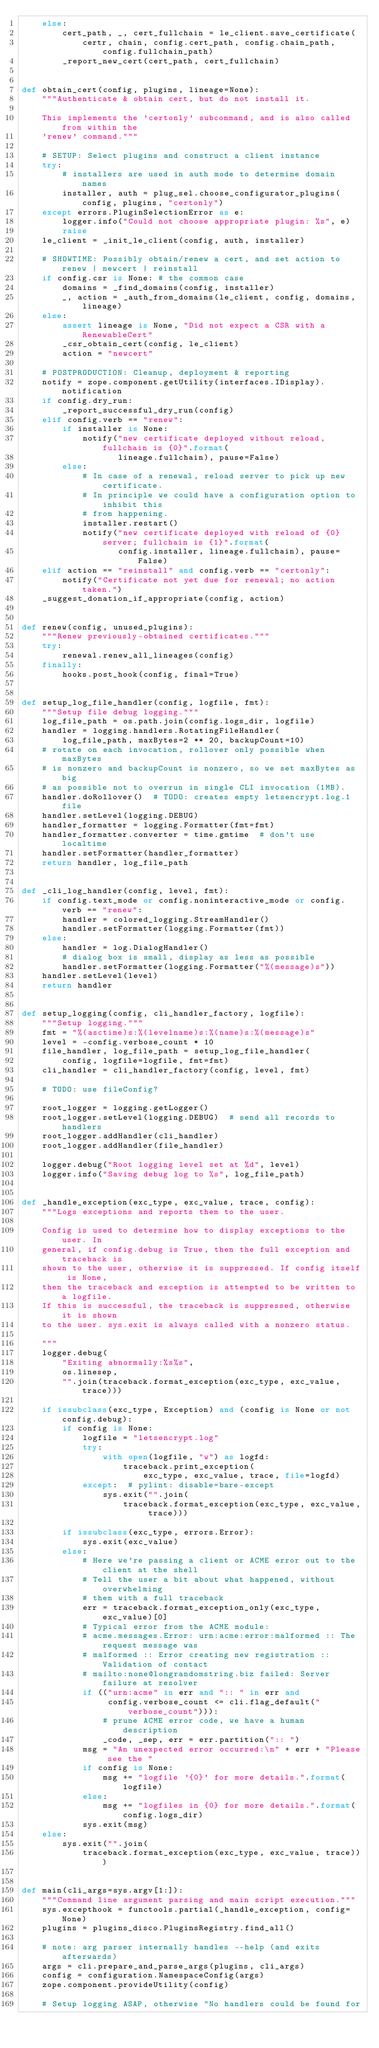Convert code to text. <code><loc_0><loc_0><loc_500><loc_500><_Python_>    else:
        cert_path, _, cert_fullchain = le_client.save_certificate(
            certr, chain, config.cert_path, config.chain_path, config.fullchain_path)
        _report_new_cert(cert_path, cert_fullchain)


def obtain_cert(config, plugins, lineage=None):
    """Authenticate & obtain cert, but do not install it.

    This implements the 'certonly' subcommand, and is also called from within the
    'renew' command."""

    # SETUP: Select plugins and construct a client instance
    try:
        # installers are used in auth mode to determine domain names
        installer, auth = plug_sel.choose_configurator_plugins(config, plugins, "certonly")
    except errors.PluginSelectionError as e:
        logger.info("Could not choose appropriate plugin: %s", e)
        raise
    le_client = _init_le_client(config, auth, installer)

    # SHOWTIME: Possibly obtain/renew a cert, and set action to renew | newcert | reinstall
    if config.csr is None: # the common case
        domains = _find_domains(config, installer)
        _, action = _auth_from_domains(le_client, config, domains, lineage)
    else:
        assert lineage is None, "Did not expect a CSR with a RenewableCert"
        _csr_obtain_cert(config, le_client)
        action = "newcert"

    # POSTPRODUCTION: Cleanup, deployment & reporting
    notify = zope.component.getUtility(interfaces.IDisplay).notification
    if config.dry_run:
        _report_successful_dry_run(config)
    elif config.verb == "renew":
        if installer is None:
            notify("new certificate deployed without reload, fullchain is {0}".format(
                   lineage.fullchain), pause=False)
        else:
            # In case of a renewal, reload server to pick up new certificate.
            # In principle we could have a configuration option to inhibit this
            # from happening.
            installer.restart()
            notify("new certificate deployed with reload of {0} server; fullchain is {1}".format(
                   config.installer, lineage.fullchain), pause=False)
    elif action == "reinstall" and config.verb == "certonly":
        notify("Certificate not yet due for renewal; no action taken.")
    _suggest_donation_if_appropriate(config, action)


def renew(config, unused_plugins):
    """Renew previously-obtained certificates."""
    try:
        renewal.renew_all_lineages(config)
    finally:
        hooks.post_hook(config, final=True)


def setup_log_file_handler(config, logfile, fmt):
    """Setup file debug logging."""
    log_file_path = os.path.join(config.logs_dir, logfile)
    handler = logging.handlers.RotatingFileHandler(
        log_file_path, maxBytes=2 ** 20, backupCount=10)
    # rotate on each invocation, rollover only possible when maxBytes
    # is nonzero and backupCount is nonzero, so we set maxBytes as big
    # as possible not to overrun in single CLI invocation (1MB).
    handler.doRollover()  # TODO: creates empty letsencrypt.log.1 file
    handler.setLevel(logging.DEBUG)
    handler_formatter = logging.Formatter(fmt=fmt)
    handler_formatter.converter = time.gmtime  # don't use localtime
    handler.setFormatter(handler_formatter)
    return handler, log_file_path


def _cli_log_handler(config, level, fmt):
    if config.text_mode or config.noninteractive_mode or config.verb == "renew":
        handler = colored_logging.StreamHandler()
        handler.setFormatter(logging.Formatter(fmt))
    else:
        handler = log.DialogHandler()
        # dialog box is small, display as less as possible
        handler.setFormatter(logging.Formatter("%(message)s"))
    handler.setLevel(level)
    return handler


def setup_logging(config, cli_handler_factory, logfile):
    """Setup logging."""
    fmt = "%(asctime)s:%(levelname)s:%(name)s:%(message)s"
    level = -config.verbose_count * 10
    file_handler, log_file_path = setup_log_file_handler(
        config, logfile=logfile, fmt=fmt)
    cli_handler = cli_handler_factory(config, level, fmt)

    # TODO: use fileConfig?

    root_logger = logging.getLogger()
    root_logger.setLevel(logging.DEBUG)  # send all records to handlers
    root_logger.addHandler(cli_handler)
    root_logger.addHandler(file_handler)

    logger.debug("Root logging level set at %d", level)
    logger.info("Saving debug log to %s", log_file_path)


def _handle_exception(exc_type, exc_value, trace, config):
    """Logs exceptions and reports them to the user.

    Config is used to determine how to display exceptions to the user. In
    general, if config.debug is True, then the full exception and traceback is
    shown to the user, otherwise it is suppressed. If config itself is None,
    then the traceback and exception is attempted to be written to a logfile.
    If this is successful, the traceback is suppressed, otherwise it is shown
    to the user. sys.exit is always called with a nonzero status.

    """
    logger.debug(
        "Exiting abnormally:%s%s",
        os.linesep,
        "".join(traceback.format_exception(exc_type, exc_value, trace)))

    if issubclass(exc_type, Exception) and (config is None or not config.debug):
        if config is None:
            logfile = "letsencrypt.log"
            try:
                with open(logfile, "w") as logfd:
                    traceback.print_exception(
                        exc_type, exc_value, trace, file=logfd)
            except:  # pylint: disable=bare-except
                sys.exit("".join(
                    traceback.format_exception(exc_type, exc_value, trace)))

        if issubclass(exc_type, errors.Error):
            sys.exit(exc_value)
        else:
            # Here we're passing a client or ACME error out to the client at the shell
            # Tell the user a bit about what happened, without overwhelming
            # them with a full traceback
            err = traceback.format_exception_only(exc_type, exc_value)[0]
            # Typical error from the ACME module:
            # acme.messages.Error: urn:acme:error:malformed :: The request message was
            # malformed :: Error creating new registration :: Validation of contact
            # mailto:none@longrandomstring.biz failed: Server failure at resolver
            if (("urn:acme" in err and ":: " in err and
                 config.verbose_count <= cli.flag_default("verbose_count"))):
                # prune ACME error code, we have a human description
                _code, _sep, err = err.partition(":: ")
            msg = "An unexpected error occurred:\n" + err + "Please see the "
            if config is None:
                msg += "logfile '{0}' for more details.".format(logfile)
            else:
                msg += "logfiles in {0} for more details.".format(config.logs_dir)
            sys.exit(msg)
    else:
        sys.exit("".join(
            traceback.format_exception(exc_type, exc_value, trace)))


def main(cli_args=sys.argv[1:]):
    """Command line argument parsing and main script execution."""
    sys.excepthook = functools.partial(_handle_exception, config=None)
    plugins = plugins_disco.PluginsRegistry.find_all()

    # note: arg parser internally handles --help (and exits afterwards)
    args = cli.prepare_and_parse_args(plugins, cli_args)
    config = configuration.NamespaceConfig(args)
    zope.component.provideUtility(config)

    # Setup logging ASAP, otherwise "No handlers could be found for</code> 